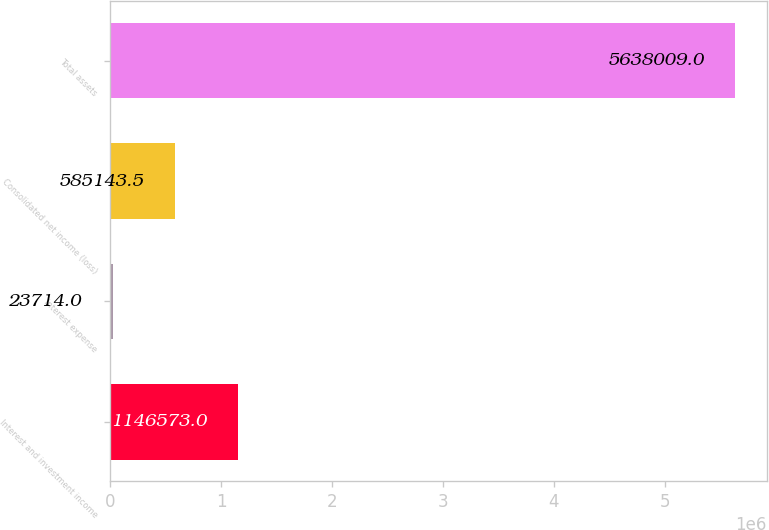Convert chart. <chart><loc_0><loc_0><loc_500><loc_500><bar_chart><fcel>Interest and investment income<fcel>Interest expense<fcel>Consolidated net income (loss)<fcel>Total assets<nl><fcel>1.14657e+06<fcel>23714<fcel>585144<fcel>5.63801e+06<nl></chart> 